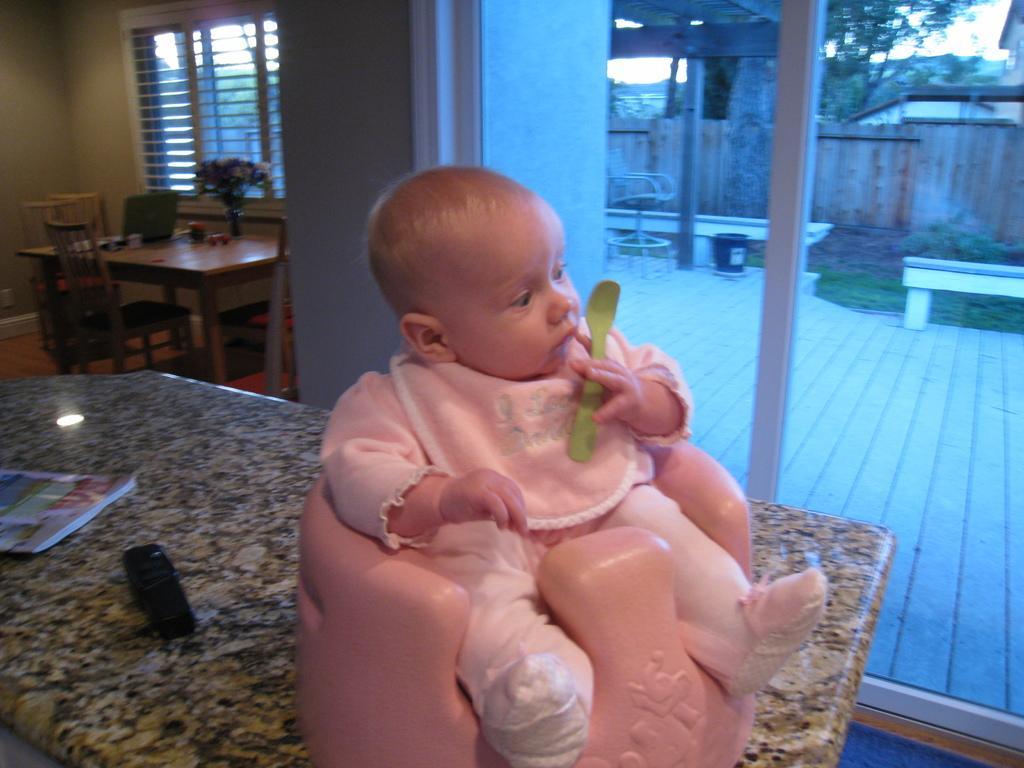Can you describe this image briefly? In this image in the front there is a kid sitting on the seat holding a spoon which is green in colour and which is on the table in the center and there is a remote and there are papers on the table. In the background there are windows and there is a table, on the table there are objects and there is a flower vase and there are empty chairs and behind the windows there are trees, there is a wooden fence and there's grass on the ground. 